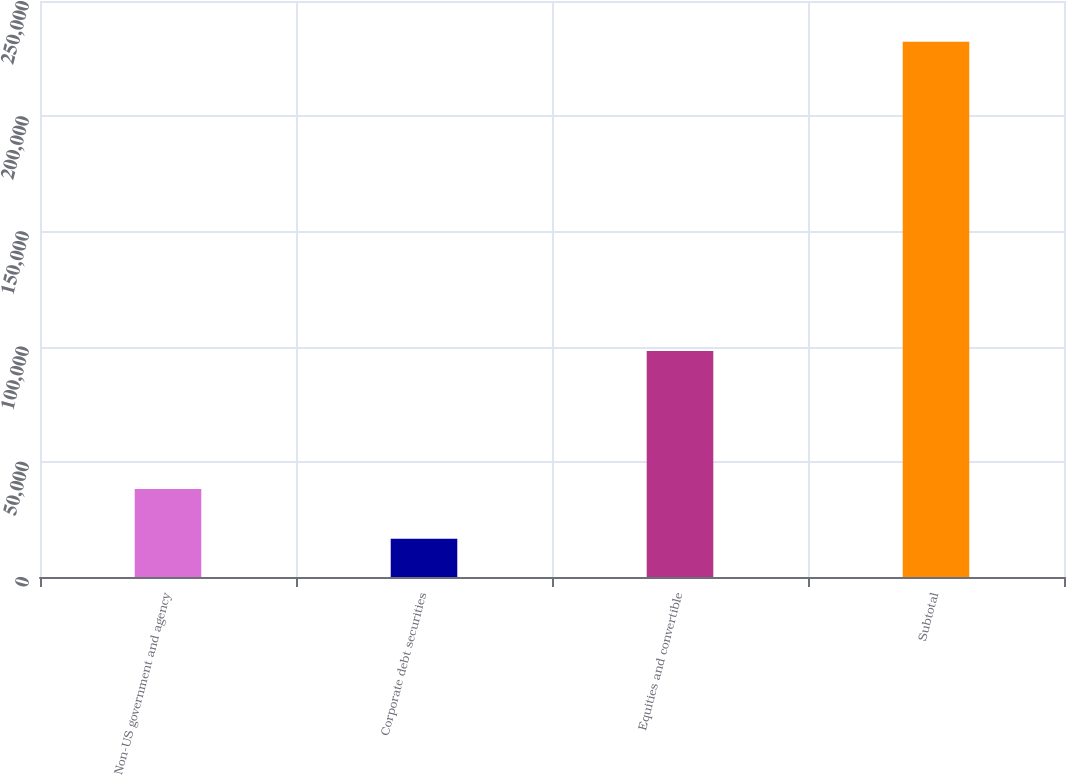Convert chart to OTSL. <chart><loc_0><loc_0><loc_500><loc_500><bar_chart><fcel>Non-US government and agency<fcel>Corporate debt securities<fcel>Equities and convertible<fcel>Subtotal<nl><fcel>38205.3<fcel>16640<fcel>98072<fcel>232293<nl></chart> 